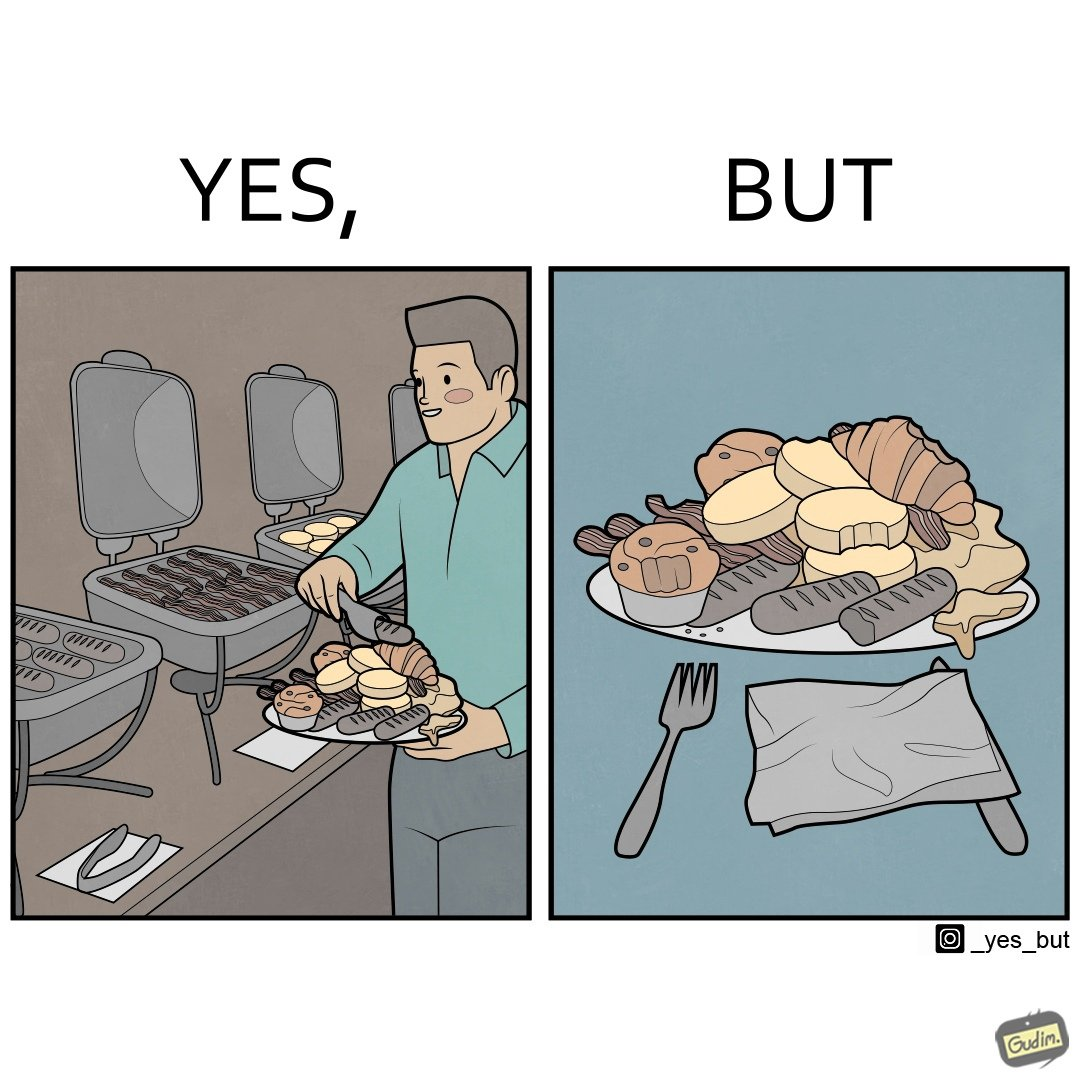Provide a description of this image. The image is satirical because while the man overfils his plate with differnt food items, he ends up wasting almost all of it by not eating them or by taking just one bite out of them leaving the rest. 